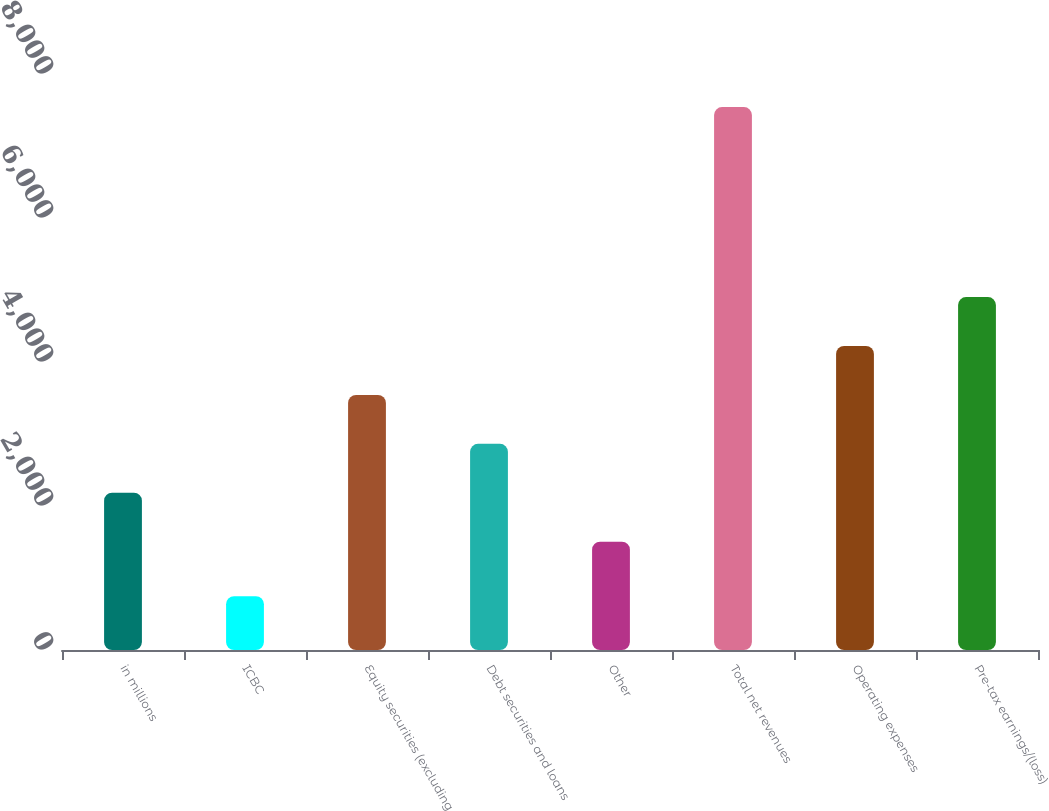Convert chart. <chart><loc_0><loc_0><loc_500><loc_500><bar_chart><fcel>in millions<fcel>ICBC<fcel>Equity securities (excluding<fcel>Debt securities and loans<fcel>Other<fcel>Total net revenues<fcel>Operating expenses<fcel>Pre-tax earnings/(loss)<nl><fcel>2184.4<fcel>747<fcel>3543.2<fcel>2863.8<fcel>1505<fcel>7541<fcel>4222.6<fcel>4902<nl></chart> 